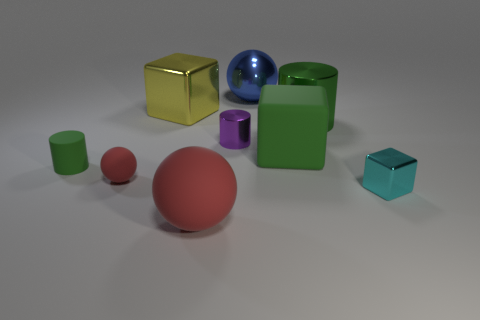Are the green thing behind the large green rubber cube and the small green cylinder made of the same material?
Give a very brief answer. No. Is there another sphere that has the same material as the blue ball?
Provide a succinct answer. No. There is a block that is both in front of the large yellow metal thing and on the left side of the green metallic cylinder; what is its color?
Offer a terse response. Green. How many other objects are there of the same color as the rubber cube?
Ensure brevity in your answer.  2. What is the material of the ball in front of the red rubber sphere left of the shiny block behind the big cylinder?
Make the answer very short. Rubber. What number of spheres are cyan metal objects or purple things?
Offer a very short reply. 0. Is there any other thing that is the same size as the cyan metal cube?
Your response must be concise. Yes. What number of tiny rubber things are right of the shiny object in front of the large matte object on the right side of the big red sphere?
Provide a short and direct response. 0. Is the blue object the same shape as the purple thing?
Provide a succinct answer. No. Are the cylinder that is to the left of the large red matte object and the small object that is on the right side of the big matte cube made of the same material?
Provide a succinct answer. No. 